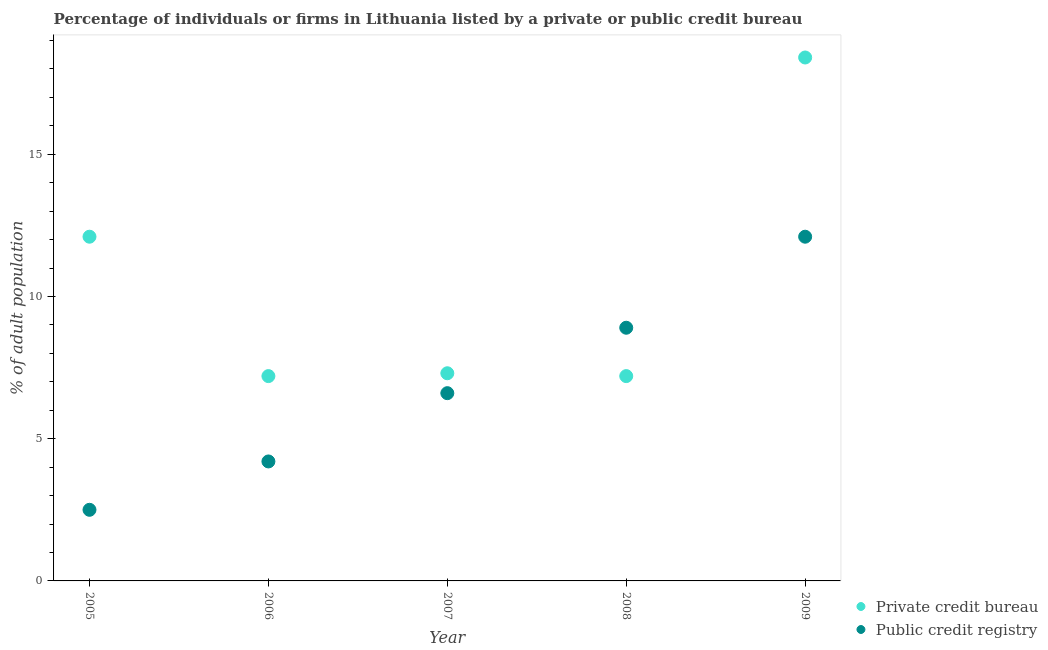How many different coloured dotlines are there?
Ensure brevity in your answer.  2. What is the percentage of firms listed by public credit bureau in 2009?
Offer a very short reply. 12.1. In which year was the percentage of firms listed by public credit bureau minimum?
Give a very brief answer. 2005. What is the total percentage of firms listed by private credit bureau in the graph?
Your answer should be compact. 52.2. What is the difference between the percentage of firms listed by private credit bureau in 2007 and the percentage of firms listed by public credit bureau in 2009?
Offer a very short reply. -4.8. What is the average percentage of firms listed by private credit bureau per year?
Your response must be concise. 10.44. In the year 2007, what is the difference between the percentage of firms listed by private credit bureau and percentage of firms listed by public credit bureau?
Your answer should be compact. 0.7. In how many years, is the percentage of firms listed by private credit bureau greater than 9 %?
Provide a succinct answer. 2. What is the ratio of the percentage of firms listed by private credit bureau in 2006 to that in 2008?
Provide a short and direct response. 1. Is the difference between the percentage of firms listed by private credit bureau in 2006 and 2008 greater than the difference between the percentage of firms listed by public credit bureau in 2006 and 2008?
Keep it short and to the point. Yes. What is the difference between the highest and the second highest percentage of firms listed by private credit bureau?
Your answer should be very brief. 6.3. What is the difference between the highest and the lowest percentage of firms listed by public credit bureau?
Your answer should be very brief. 9.6. Does the percentage of firms listed by public credit bureau monotonically increase over the years?
Offer a terse response. Yes. Is the percentage of firms listed by private credit bureau strictly greater than the percentage of firms listed by public credit bureau over the years?
Give a very brief answer. No. How many years are there in the graph?
Your answer should be very brief. 5. Where does the legend appear in the graph?
Make the answer very short. Bottom right. How many legend labels are there?
Your response must be concise. 2. How are the legend labels stacked?
Provide a short and direct response. Vertical. What is the title of the graph?
Your answer should be very brief. Percentage of individuals or firms in Lithuania listed by a private or public credit bureau. What is the label or title of the X-axis?
Provide a succinct answer. Year. What is the label or title of the Y-axis?
Provide a short and direct response. % of adult population. What is the % of adult population in Public credit registry in 2005?
Make the answer very short. 2.5. What is the % of adult population of Private credit bureau in 2007?
Provide a short and direct response. 7.3. What is the % of adult population of Private credit bureau in 2008?
Your answer should be very brief. 7.2. What is the % of adult population of Public credit registry in 2008?
Provide a succinct answer. 8.9. What is the total % of adult population of Private credit bureau in the graph?
Make the answer very short. 52.2. What is the total % of adult population of Public credit registry in the graph?
Your answer should be very brief. 34.3. What is the difference between the % of adult population in Private credit bureau in 2005 and that in 2006?
Offer a very short reply. 4.9. What is the difference between the % of adult population in Private credit bureau in 2005 and that in 2007?
Provide a succinct answer. 4.8. What is the difference between the % of adult population of Public credit registry in 2005 and that in 2007?
Provide a succinct answer. -4.1. What is the difference between the % of adult population in Private credit bureau in 2005 and that in 2009?
Your answer should be compact. -6.3. What is the difference between the % of adult population of Private credit bureau in 2006 and that in 2007?
Offer a terse response. -0.1. What is the difference between the % of adult population in Public credit registry in 2006 and that in 2007?
Give a very brief answer. -2.4. What is the difference between the % of adult population of Private credit bureau in 2006 and that in 2008?
Ensure brevity in your answer.  0. What is the difference between the % of adult population of Public credit registry in 2006 and that in 2008?
Your answer should be compact. -4.7. What is the difference between the % of adult population of Private credit bureau in 2006 and that in 2009?
Your response must be concise. -11.2. What is the difference between the % of adult population in Private credit bureau in 2007 and that in 2009?
Provide a succinct answer. -11.1. What is the difference between the % of adult population in Private credit bureau in 2005 and the % of adult population in Public credit registry in 2006?
Provide a short and direct response. 7.9. What is the difference between the % of adult population in Private credit bureau in 2005 and the % of adult population in Public credit registry in 2008?
Make the answer very short. 3.2. What is the difference between the % of adult population in Private credit bureau in 2005 and the % of adult population in Public credit registry in 2009?
Give a very brief answer. 0. What is the difference between the % of adult population in Private credit bureau in 2006 and the % of adult population in Public credit registry in 2007?
Keep it short and to the point. 0.6. What is the difference between the % of adult population in Private credit bureau in 2006 and the % of adult population in Public credit registry in 2008?
Make the answer very short. -1.7. What is the average % of adult population in Private credit bureau per year?
Offer a very short reply. 10.44. What is the average % of adult population of Public credit registry per year?
Your answer should be compact. 6.86. In the year 2007, what is the difference between the % of adult population of Private credit bureau and % of adult population of Public credit registry?
Your answer should be compact. 0.7. In the year 2009, what is the difference between the % of adult population of Private credit bureau and % of adult population of Public credit registry?
Your response must be concise. 6.3. What is the ratio of the % of adult population of Private credit bureau in 2005 to that in 2006?
Offer a very short reply. 1.68. What is the ratio of the % of adult population of Public credit registry in 2005 to that in 2006?
Keep it short and to the point. 0.6. What is the ratio of the % of adult population of Private credit bureau in 2005 to that in 2007?
Ensure brevity in your answer.  1.66. What is the ratio of the % of adult population of Public credit registry in 2005 to that in 2007?
Your response must be concise. 0.38. What is the ratio of the % of adult population in Private credit bureau in 2005 to that in 2008?
Provide a succinct answer. 1.68. What is the ratio of the % of adult population in Public credit registry in 2005 to that in 2008?
Ensure brevity in your answer.  0.28. What is the ratio of the % of adult population of Private credit bureau in 2005 to that in 2009?
Give a very brief answer. 0.66. What is the ratio of the % of adult population of Public credit registry in 2005 to that in 2009?
Make the answer very short. 0.21. What is the ratio of the % of adult population of Private credit bureau in 2006 to that in 2007?
Provide a short and direct response. 0.99. What is the ratio of the % of adult population of Public credit registry in 2006 to that in 2007?
Offer a very short reply. 0.64. What is the ratio of the % of adult population in Public credit registry in 2006 to that in 2008?
Keep it short and to the point. 0.47. What is the ratio of the % of adult population in Private credit bureau in 2006 to that in 2009?
Ensure brevity in your answer.  0.39. What is the ratio of the % of adult population of Public credit registry in 2006 to that in 2009?
Give a very brief answer. 0.35. What is the ratio of the % of adult population of Private credit bureau in 2007 to that in 2008?
Give a very brief answer. 1.01. What is the ratio of the % of adult population in Public credit registry in 2007 to that in 2008?
Offer a terse response. 0.74. What is the ratio of the % of adult population in Private credit bureau in 2007 to that in 2009?
Your response must be concise. 0.4. What is the ratio of the % of adult population in Public credit registry in 2007 to that in 2009?
Your answer should be compact. 0.55. What is the ratio of the % of adult population in Private credit bureau in 2008 to that in 2009?
Your response must be concise. 0.39. What is the ratio of the % of adult population in Public credit registry in 2008 to that in 2009?
Offer a terse response. 0.74. What is the difference between the highest and the second highest % of adult population of Public credit registry?
Offer a terse response. 3.2. What is the difference between the highest and the lowest % of adult population of Private credit bureau?
Ensure brevity in your answer.  11.2. What is the difference between the highest and the lowest % of adult population in Public credit registry?
Ensure brevity in your answer.  9.6. 